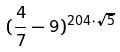Convert formula to latex. <formula><loc_0><loc_0><loc_500><loc_500>( \frac { 4 } { 7 } - 9 ) ^ { 2 0 4 \cdot \sqrt { 5 } }</formula> 